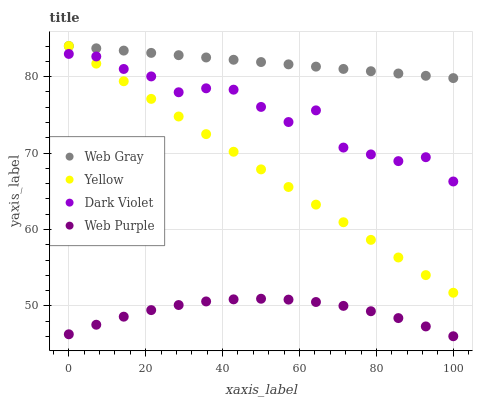Does Web Purple have the minimum area under the curve?
Answer yes or no. Yes. Does Web Gray have the maximum area under the curve?
Answer yes or no. Yes. Does Dark Violet have the minimum area under the curve?
Answer yes or no. No. Does Dark Violet have the maximum area under the curve?
Answer yes or no. No. Is Yellow the smoothest?
Answer yes or no. Yes. Is Dark Violet the roughest?
Answer yes or no. Yes. Is Web Gray the smoothest?
Answer yes or no. No. Is Web Gray the roughest?
Answer yes or no. No. Does Web Purple have the lowest value?
Answer yes or no. Yes. Does Dark Violet have the lowest value?
Answer yes or no. No. Does Yellow have the highest value?
Answer yes or no. Yes. Does Dark Violet have the highest value?
Answer yes or no. No. Is Web Purple less than Web Gray?
Answer yes or no. Yes. Is Yellow greater than Web Purple?
Answer yes or no. Yes. Does Web Gray intersect Yellow?
Answer yes or no. Yes. Is Web Gray less than Yellow?
Answer yes or no. No. Is Web Gray greater than Yellow?
Answer yes or no. No. Does Web Purple intersect Web Gray?
Answer yes or no. No. 